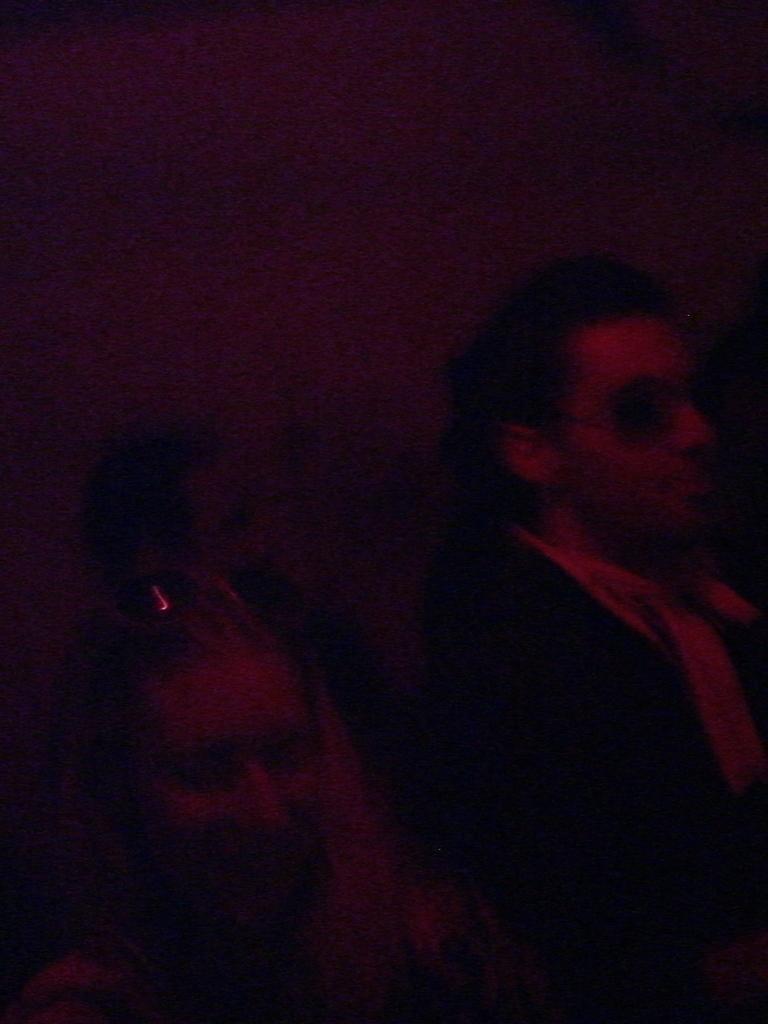Could you give a brief overview of what you see in this image? It is a dark image, it looks like there are two people in the foreground and behind them there is another person. 